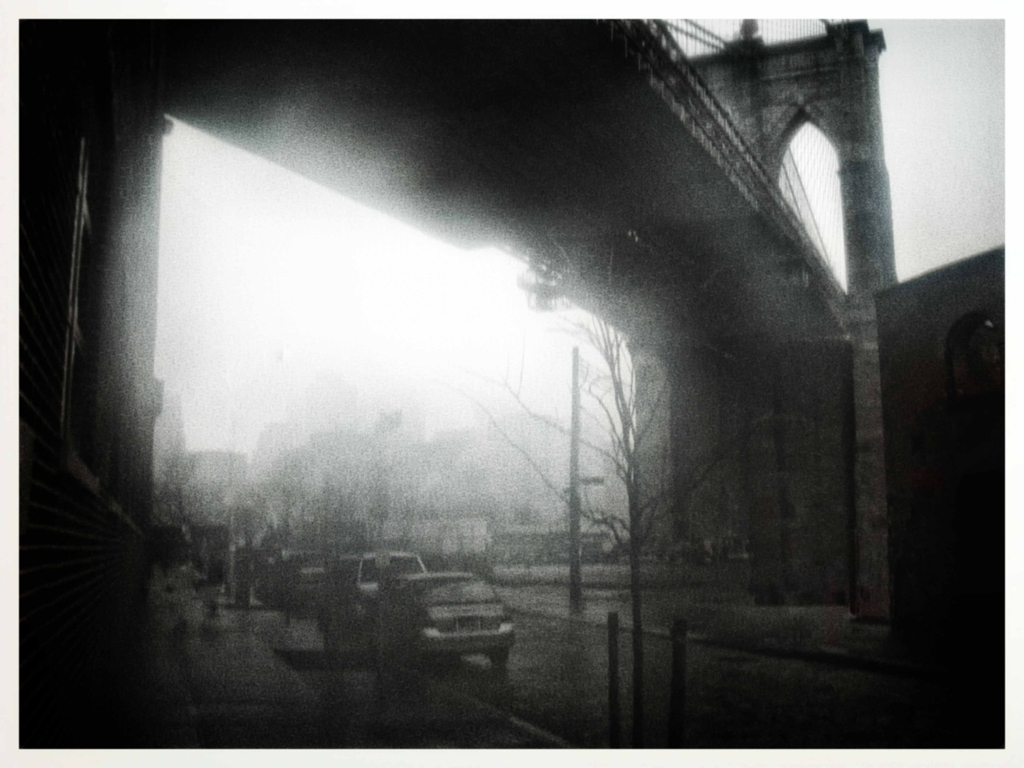Can you describe the mood or atmosphere this image conveys? The image exudes a solemn and contemplative mood, underscored by the foggy, overcast sky and the subdued grayscale color scheme. It suggests a serene yet melancholic atmosphere, possibly early morning or during a dreary day, which is further emphasized by the silhouettes and the soft outlines of the bridge and buildings. 